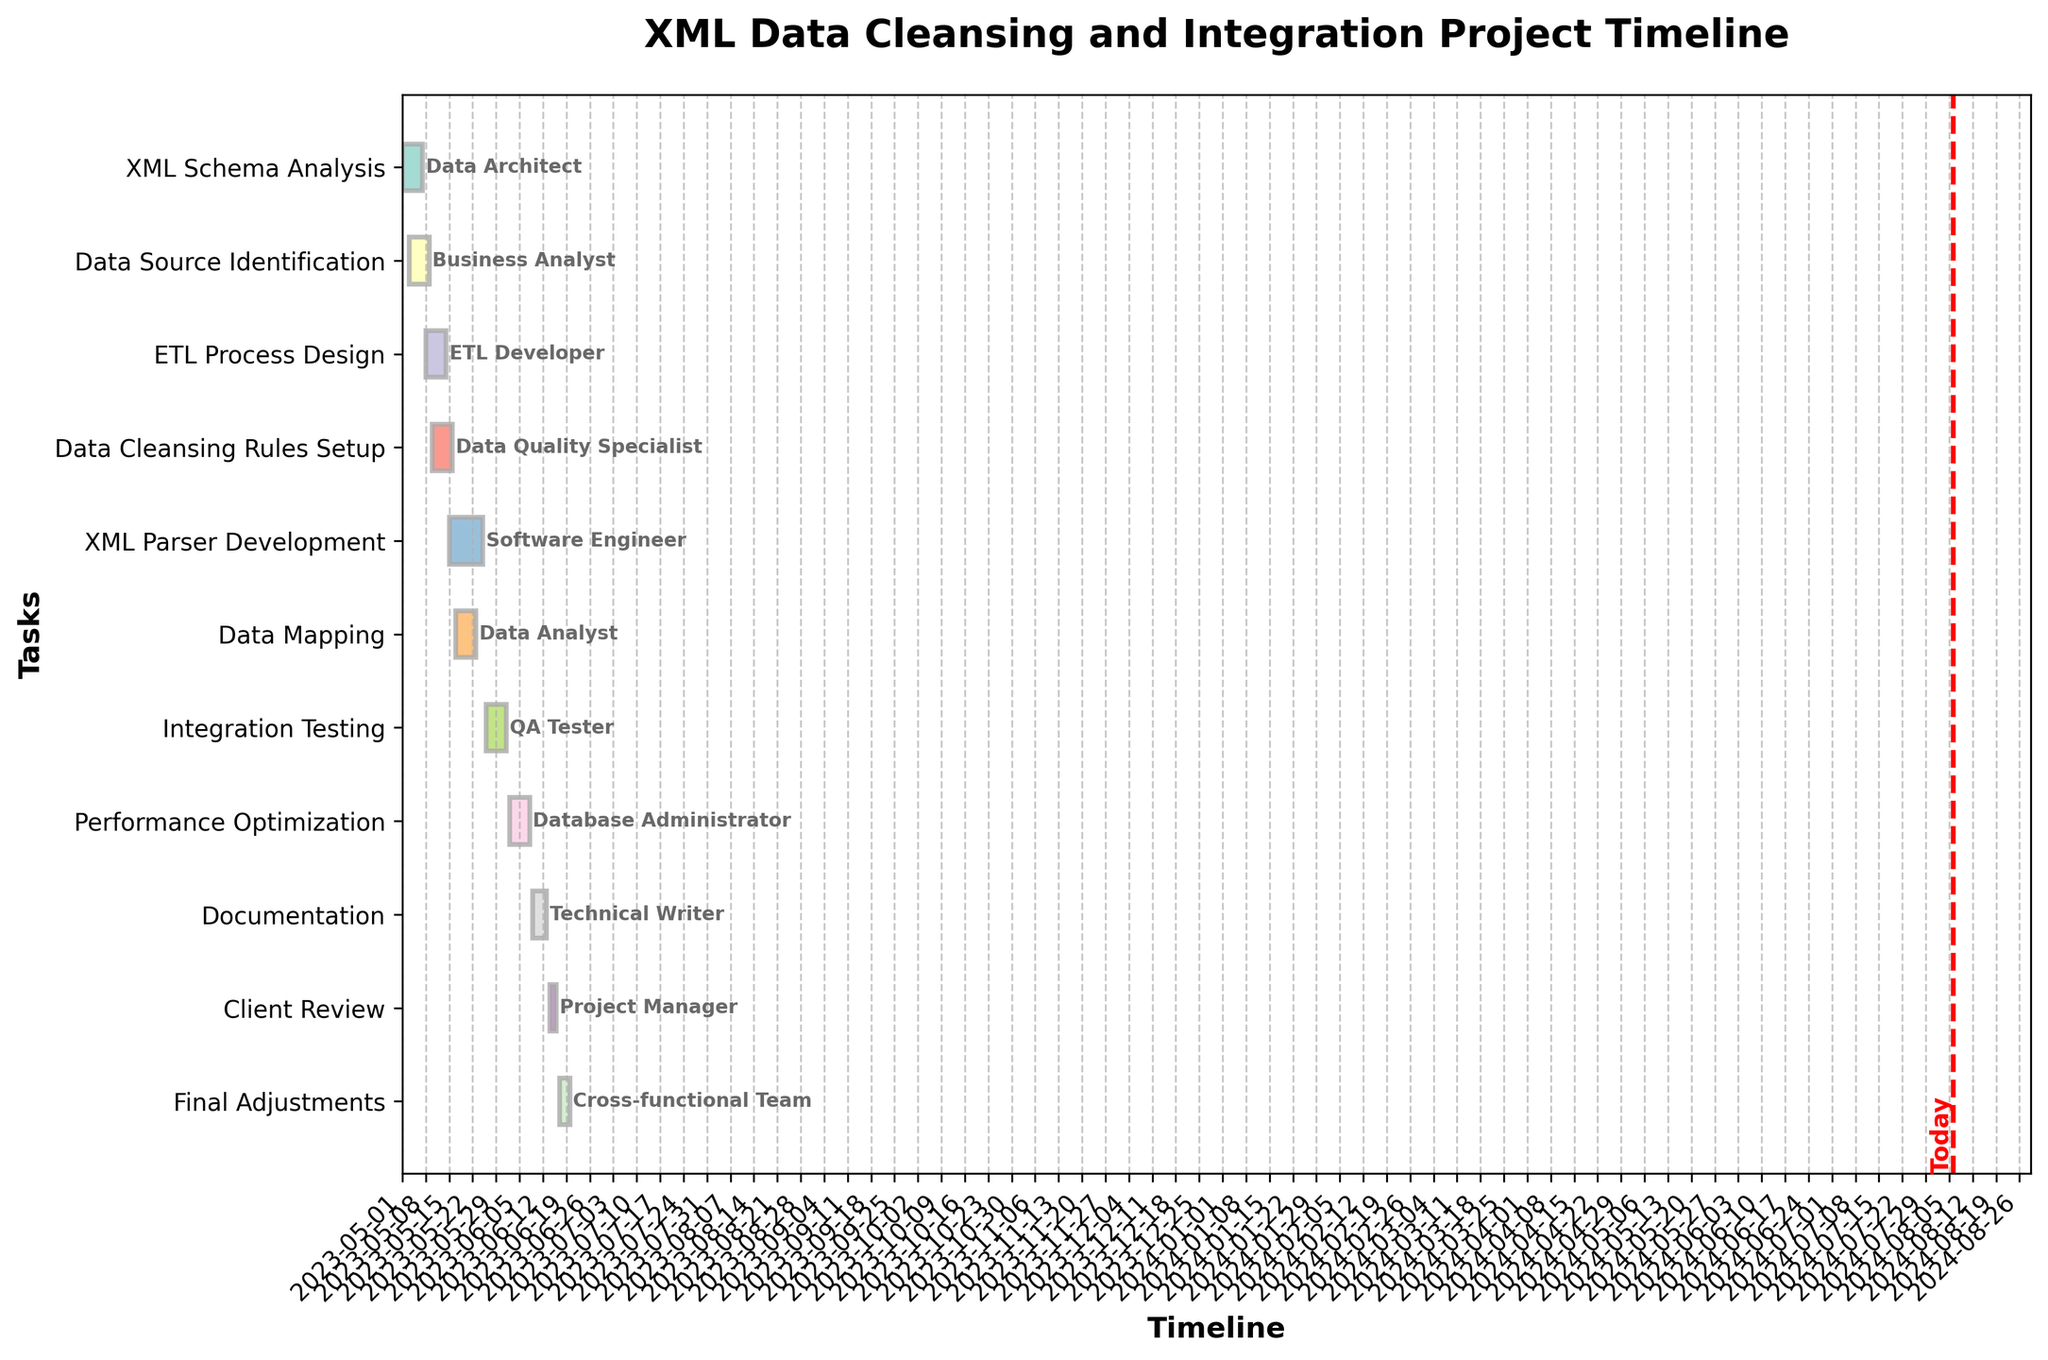what is the title of the plot? The title of the plot is usually found at the top and gives a brief summary of what the plot represents.
Answer: XML Data Cleansing and Integration Project Timeline When does the task "ETL Process Design" start and end? The tasks are labeled on the y-axis and the timeline on the x-axis indicates when each task starts and ends. "ETL Process Design" starts on 2023-05-08 and ends on 2023-05-14.
Answer: 2023-05-08 to 2023-05-14 Who is responsible for the "XML Schema Analysis" task? The person responsible is usually labeled at the end of the task bar in the Gantt chart. For "XML Schema Analysis", it is the Data Architect.
Answer: Data Architect Which task takes the longest duration and what is the duration? By comparing the lengths of the horizontal bars, the longest one represents the task with the longest duration. "XML Parser Development" takes 11 days.
Answer: XML Parser Development, 11 days How many days is the "Client Review" task scheduled for? Check the duration of the "Client Review" task by looking across the timeline. It starts on 2023-06-14 and ends on 2023-06-16, which is 3 days.
Answer: 3 days What are the start and end dates of the "Final Adjustments" task? Locate the "Final Adjustments" task on the y-axis and read off its start and end dates from the x-axis. This task starts on 2023-06-17 and ends on 2023-06-20.
Answer: 2023-06-17 to 2023-06-20 Which tasks are being worked on concurrently with "Data Source Identification"? The "Data Source Identification" task starts on 2023-05-03 and ends on 2023-05-09. Tasks overlapping these dates are running concurrently. The overlapping tasks are "XML Schema Analysis" and "ETL Process Design".
Answer: "XML Schema Analysis", "ETL Process Design" What is the total project duration? The project's duration is the timespan from the start of the first task to the end of the last task. The first task starts on 2023-05-01 and the last task ends on 2023-06-20, so the total duration is 51 days.
Answer: 51 days How many tasks are shorter than a week? Count the number of tasks with durations less than 7 days by looking at their bars on the chart. "Documentation" and "Client Review" are less than a week.
Answer: 2 tasks Which task uses the "QA Tester" resource and when is it scheduled? Follow the labels given at the end of the bars and identify which one corresponds to the "QA Tester". The task is "Integration Testing", scheduled from 2023-05-26 to 2023-06-01.
Answer: Integration Testing, 2023-05-26 to 2023-06-01 